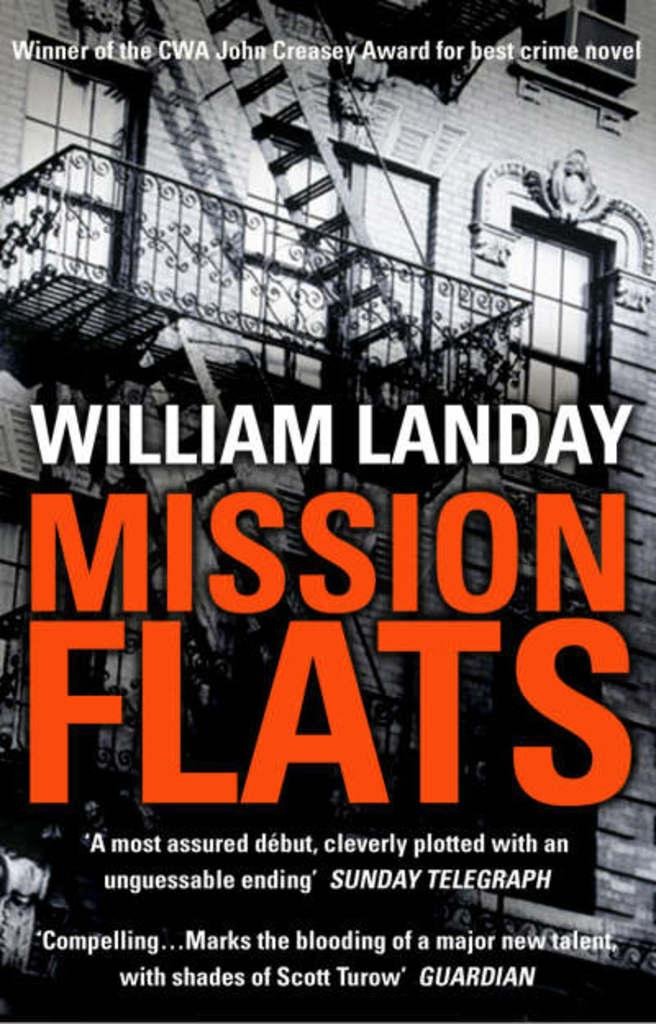<image>
Describe the image concisely. The cover of the book Mission Flats written by William Landay. 